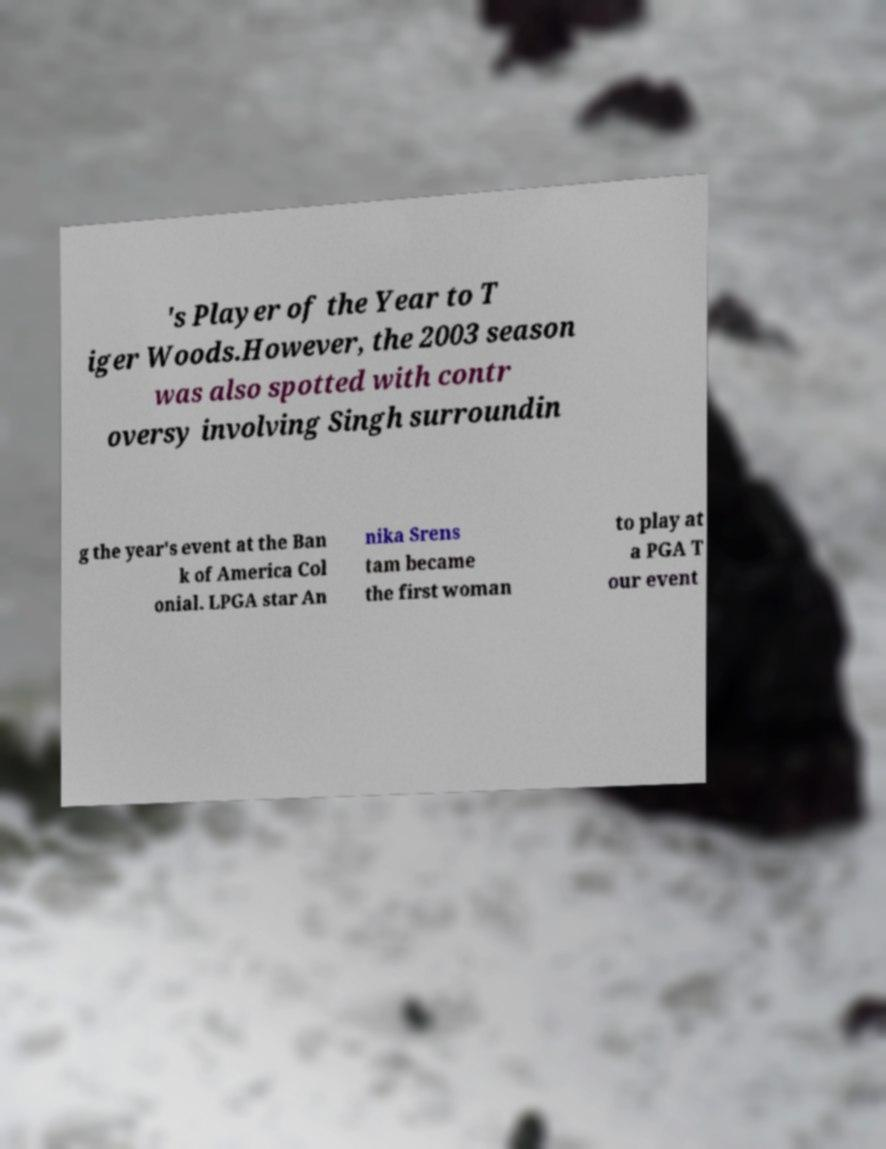Could you extract and type out the text from this image? 's Player of the Year to T iger Woods.However, the 2003 season was also spotted with contr oversy involving Singh surroundin g the year's event at the Ban k of America Col onial. LPGA star An nika Srens tam became the first woman to play at a PGA T our event 